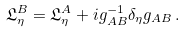Convert formula to latex. <formula><loc_0><loc_0><loc_500><loc_500>\mathfrak { L } _ { \eta } ^ { B } = \mathfrak { L } _ { \eta } ^ { A } + i g _ { A B } ^ { - 1 } \delta _ { \eta } g _ { A B } \, .</formula> 